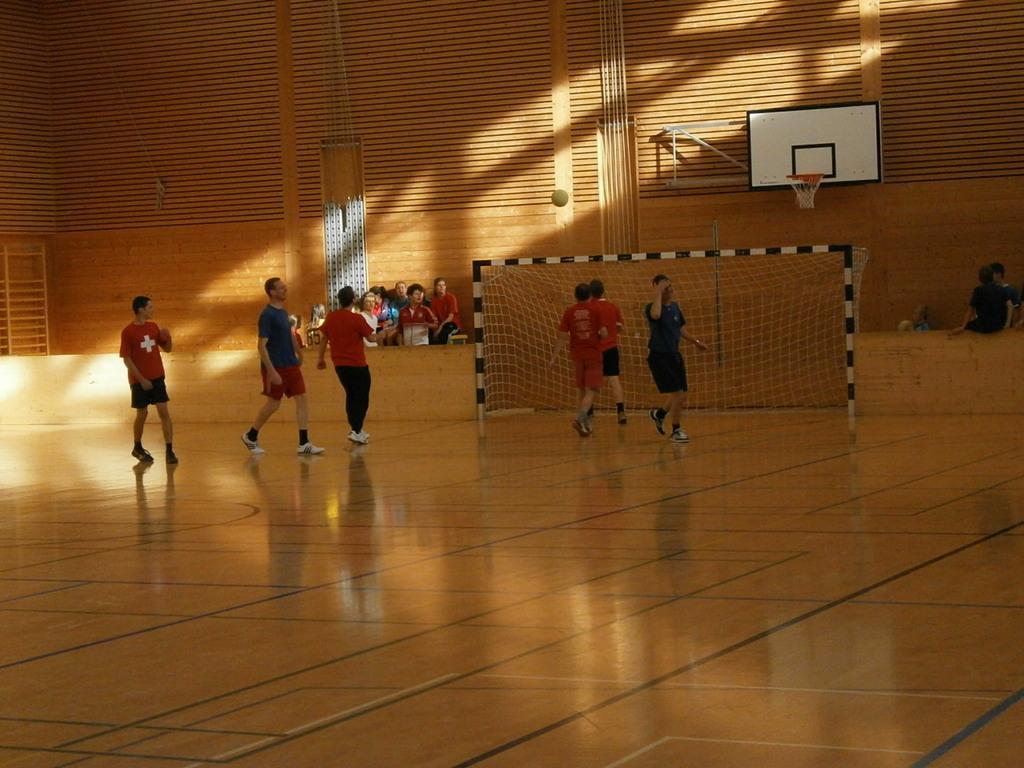How would you summarize this image in a sentence or two? In this image there are a few people standing on the floor and there are a few people sitting. There is a net, basketball court. There is a wall, ladder and a ball. 